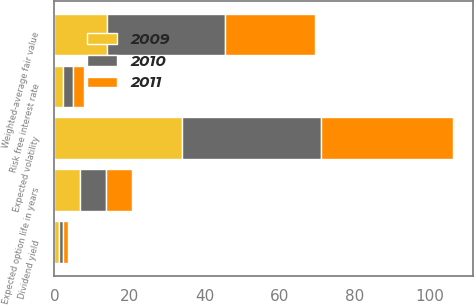Convert chart. <chart><loc_0><loc_0><loc_500><loc_500><stacked_bar_chart><ecel><fcel>Dividend yield<fcel>Expected volatility<fcel>Risk free interest rate<fcel>Expected option life in years<fcel>Weighted-average fair value<nl><fcel>2010<fcel>1.2<fcel>37<fcel>2.8<fcel>6.9<fcel>31.38<nl><fcel>2011<fcel>1.3<fcel>35<fcel>2.9<fcel>6.9<fcel>24.13<nl><fcel>2009<fcel>1.2<fcel>34<fcel>2.2<fcel>6.9<fcel>13.92<nl></chart> 